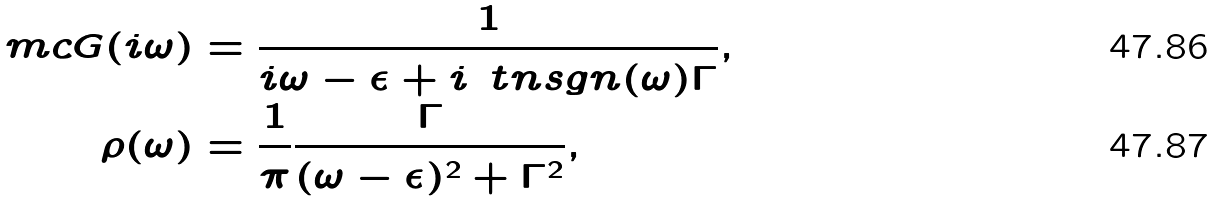Convert formula to latex. <formula><loc_0><loc_0><loc_500><loc_500>\ m c G ( i \omega ) & = \frac { 1 } { i \omega - \epsilon + i \, \ t n { s g n } ( \omega ) \Gamma } , \\ \rho ( \omega ) & = \frac { 1 } { \pi } \frac { \Gamma } { ( \omega - \epsilon ) ^ { 2 } + \Gamma ^ { 2 } } ,</formula> 